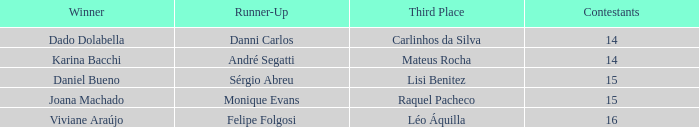Who was the winner when Mateus Rocha finished in 3rd place?  Karina Bacchi. 